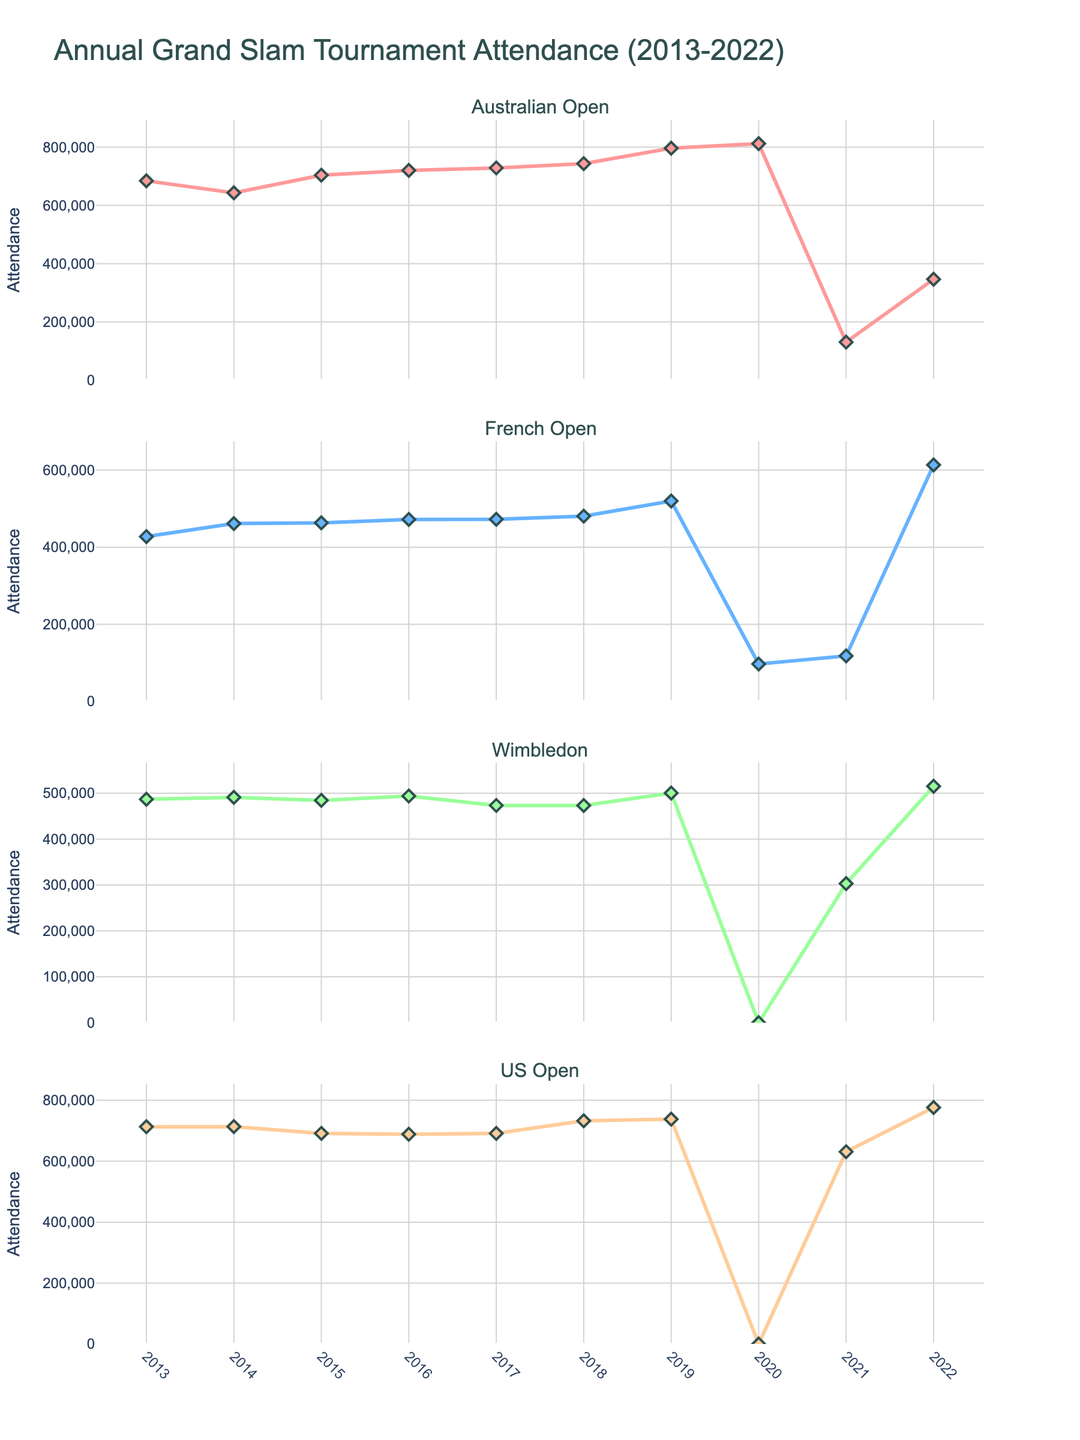What's the title of the figure? The title of the figure is typically located at the top of the visual, prominently displayed. In this case, it can be seen as "Annual Grand Slam Tournament Attendance (2013-2022)"
Answer: Annual Grand Slam Tournament Attendance (2013-2022) How many subplots are in the figure? The figure consists of individual plots stacked vertically, each representing a different Grand Slam tournament. Counting these subplots yields four.
Answer: 4 Which Grand Slam tournament had the highest attendance in 2019? To determine this, examine the 2019 attendance values for each tournament and identify the maximum value. The Australian Open had 796,435 attendees, which is the highest.
Answer: Australian Open What was the attendance for the US Open in 2020? The figure indicates a distinct reduction for the US Open in 2020. By observing the value point for that year, the attendance is zero.
Answer: 0 Which year saw the lowest attendance for Wimbledon? By tracking the attendance values for Wimbledon across years, 2020 shows the lowest value with an attendance of zero, related to the event being canceled.
Answer: 2020 How did the attendance of the French Open change from 2020 to 2021? Examine the values for the French Open in these specific years: 97,000 in 2020 and 118,000 in 2021. Calculating the difference gives an increase of 21,000.
Answer: Increased by 21,000 Compare the attendance trend of the Australian Open and the US Open between 2019 and 2021. Observe the values for both tournaments in 2019, 2020, and 2021. The Australian Open declined from 796,435 in 2019 to 130,374 in 2021, whereas the US Open fell from 737,919 in 2019 to 631,134 in 2021. Both show a decrease, but the magnitude differs substantially.
Answer: Both decreased, but Australian Open decreased more What is the average attendance for the French Open from 2016 to 2018? Calculate the sum of attendances for the French Open from 2016 to 2018 and divide by the number of years: (472,172 + 472,524 + 480,575) / 3 = 475,090.33.
Answer: 475,090.33 Which tournament showed a significant increase in attendance from 2021 to 2022? Compare the 2021 and 2022 attendance data for each tournament. The French Open showed a substantial increase from 118,000 in 2021 to 613,500 in 2022.
Answer: French Open How did the total Grand Slam attendance change from 2019 to 2020? Sum the attendances for all tournaments in both years and compare: (2019 total = 796,435 + 520,000 + 500,397 + 737,919 = 2,554,751, 2020 total = 812,174 + 97,000 + 0 + 0 = 909,174). Subtracting gives a decrease of 1,645,577.
Answer: Decreased by 1,645,577 